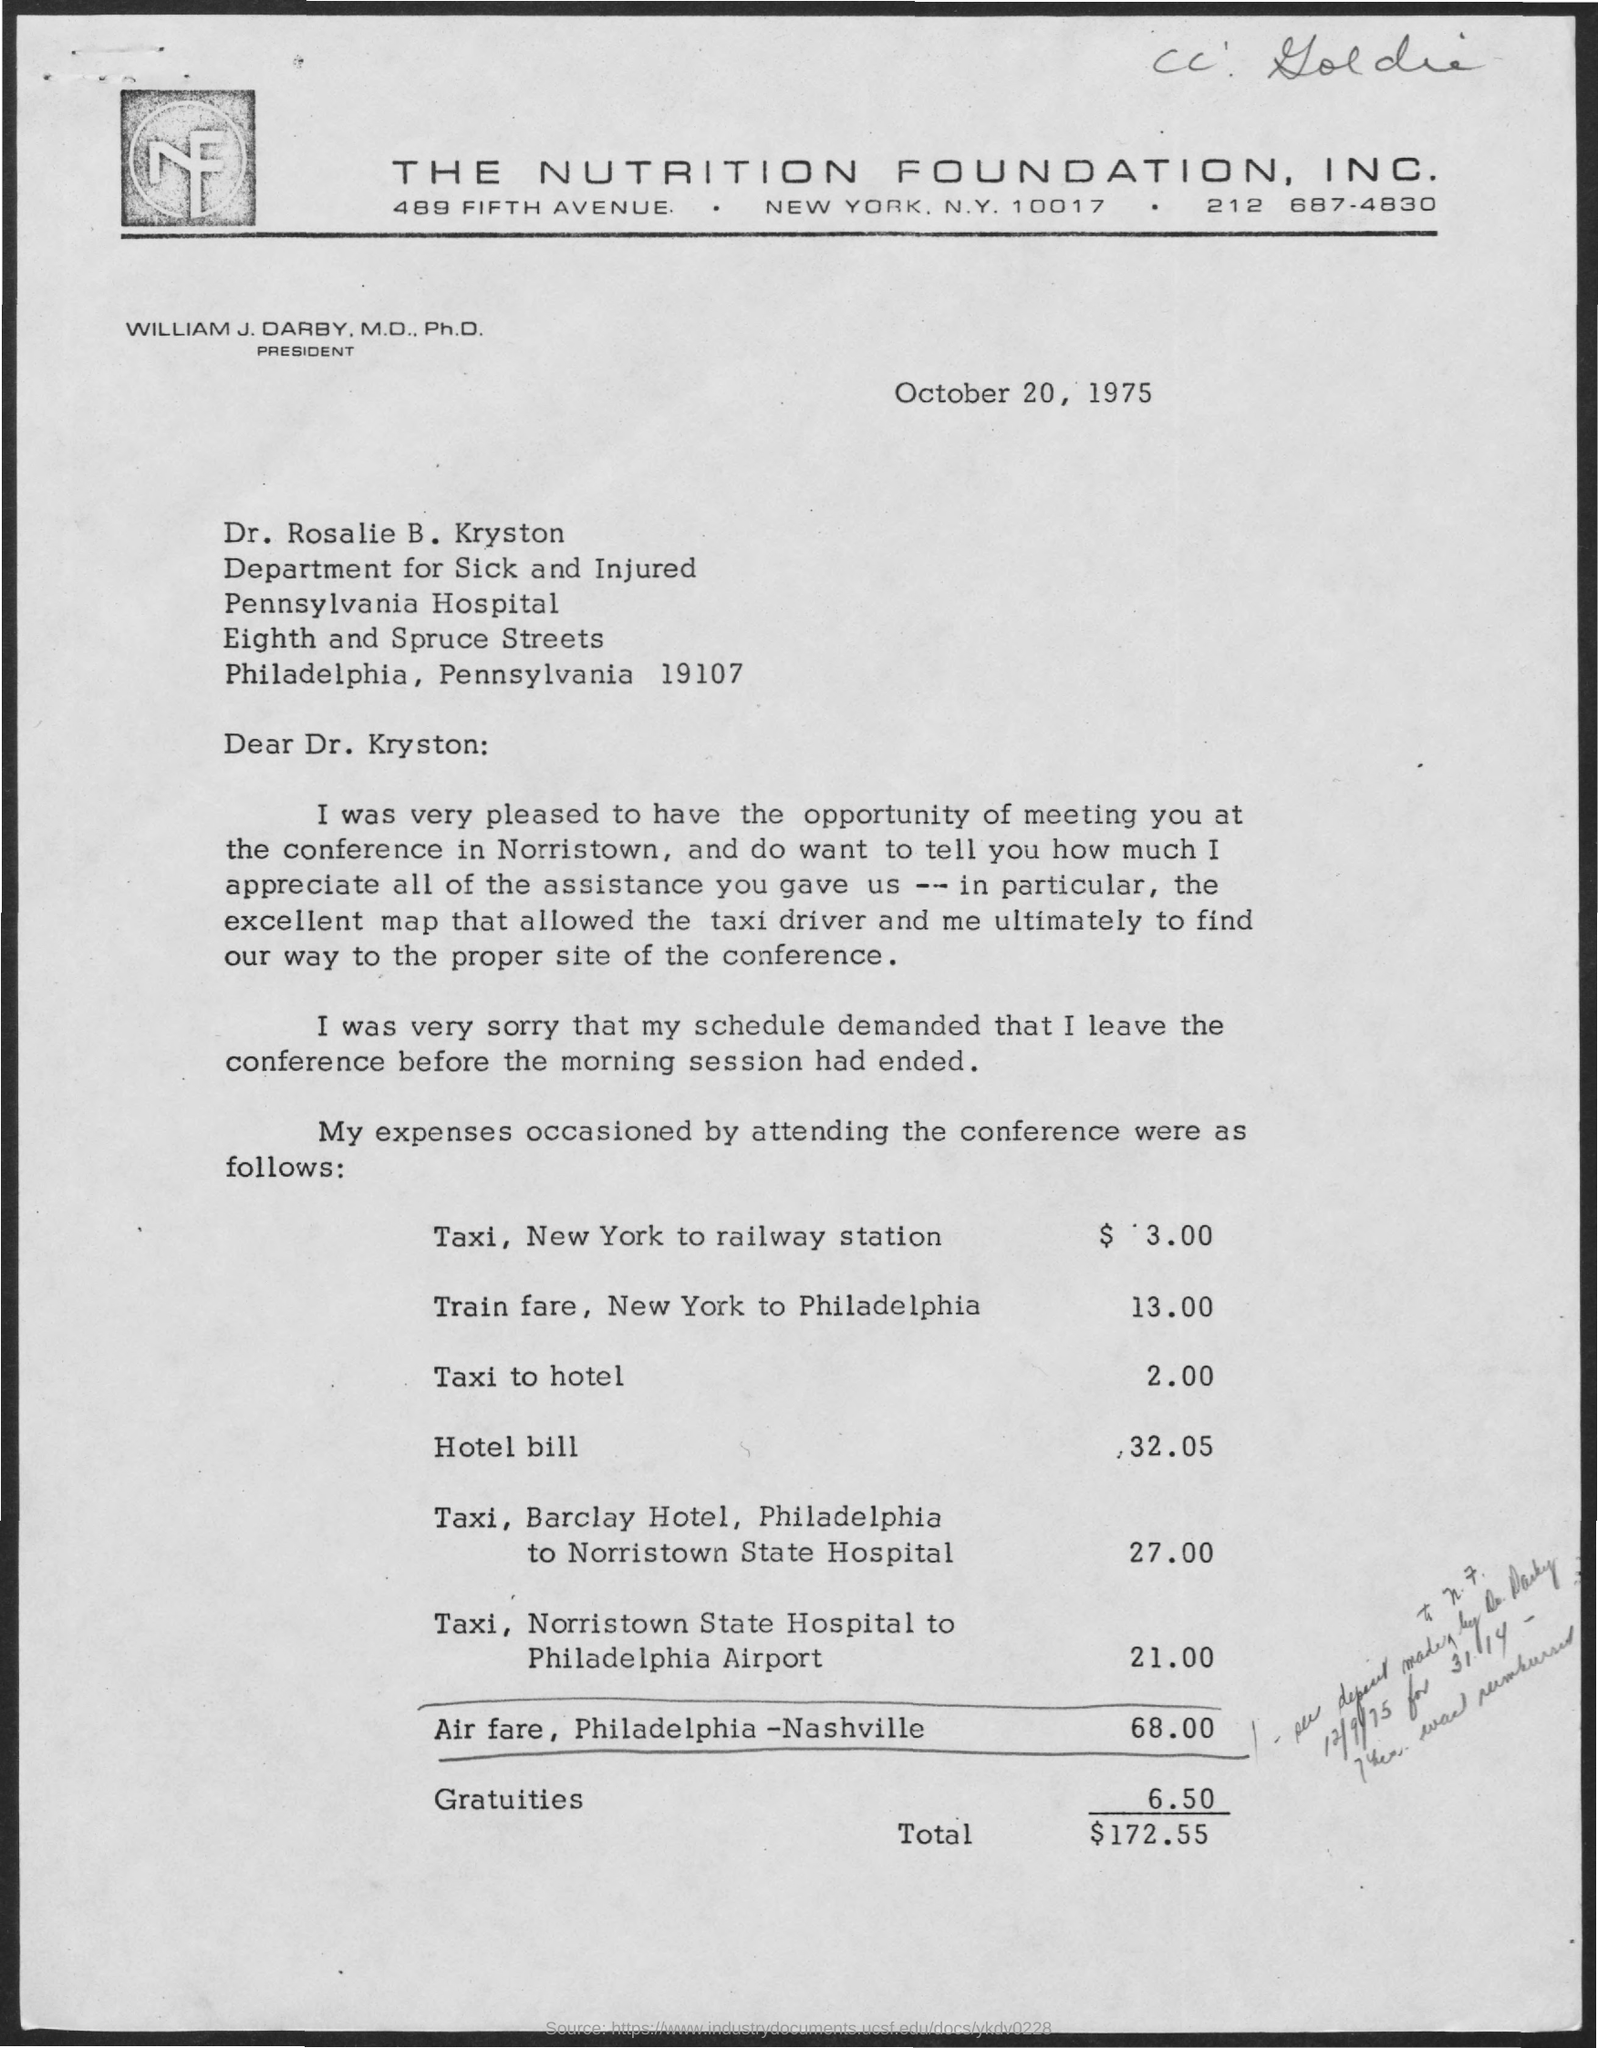Draw attention to some important aspects in this diagram. The letter is from "THE NUTRITION FOUNDATION, INC." as indicated in the letterhead. The memorandum is dated October 20, 1975. The hotel bill amounted to $32.05. 